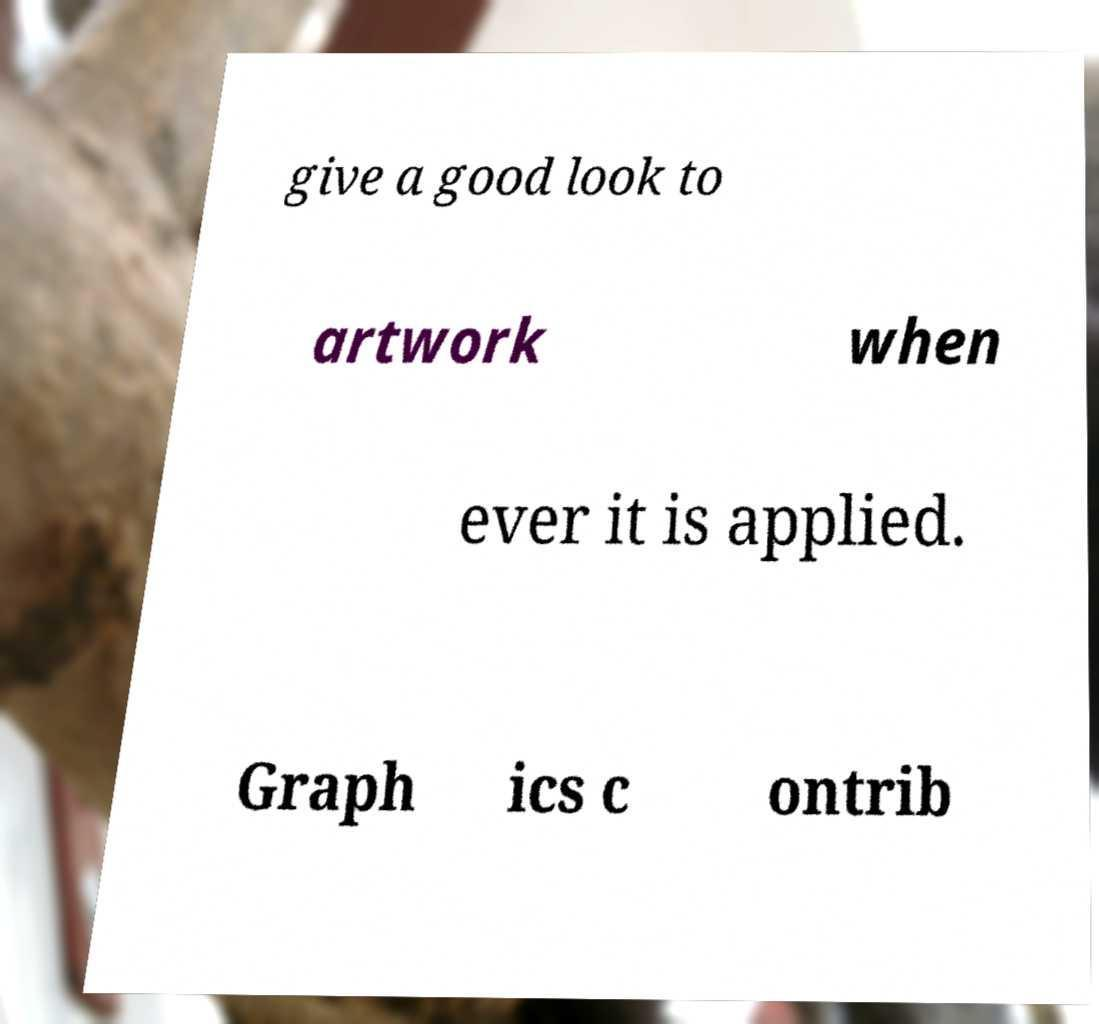For documentation purposes, I need the text within this image transcribed. Could you provide that? give a good look to artwork when ever it is applied. Graph ics c ontrib 